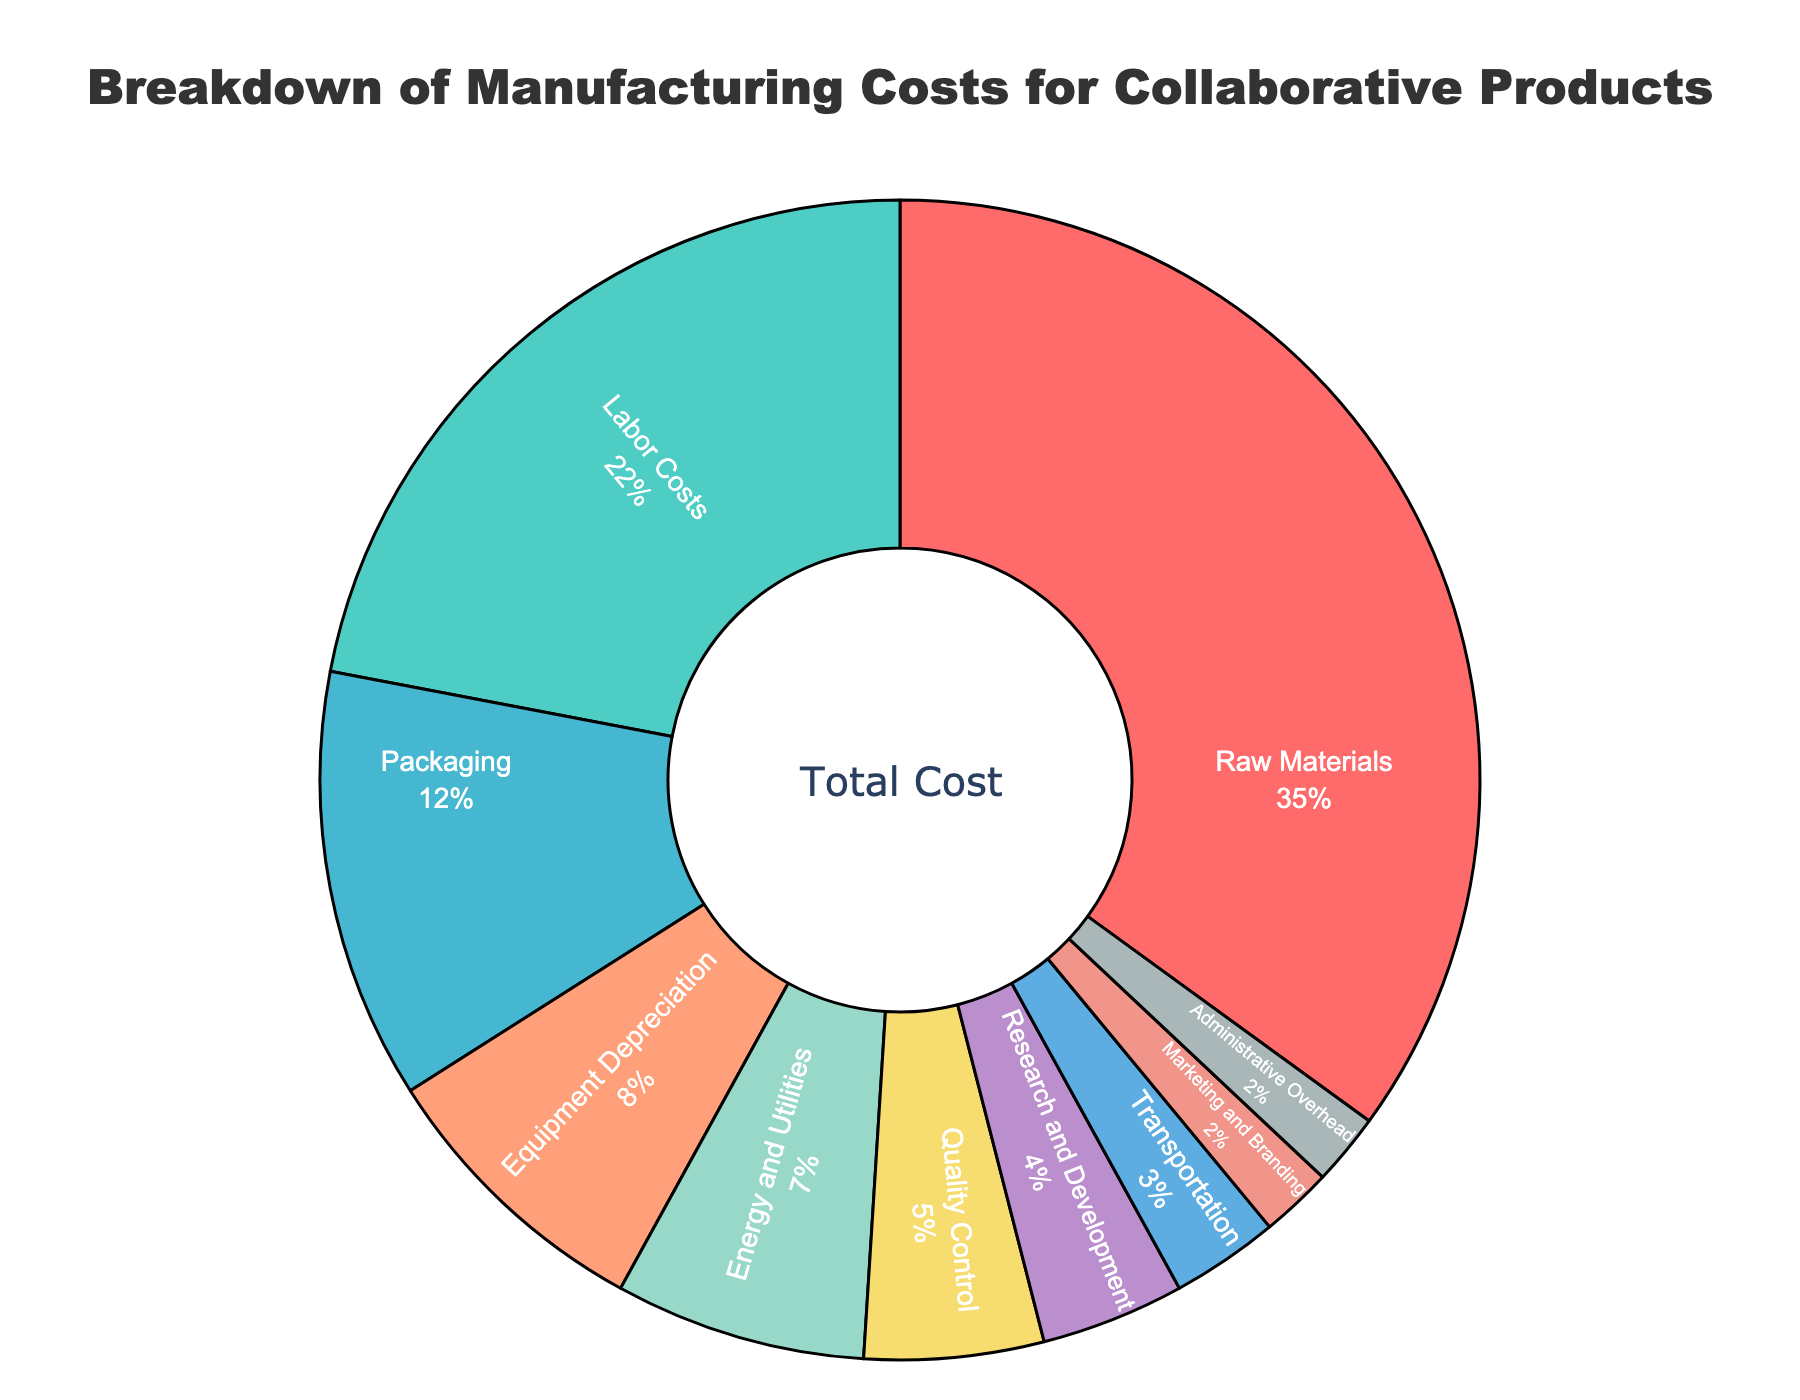what category has the highest percentage in the manufacturing costs? The highest percentage can be identified by observing the largest section of the pie chart. The category with the highest value in the figure is the Raw Materials section, which accounts for 35% of the costs.
Answer: Raw Materials what is the combined percentage of Labor Costs and Packaging? Sum the percentages of Labor Costs (22%) and Packaging (12%) to get the combined value. 22% + 12% equals 34%.
Answer: 34% how does the percentage of Equipment Depreciation compare to Quality Control? Equipment Depreciation has 8% while Quality Control has 5%. Since 8% is greater than 5%, Equipment Depreciation is higher.
Answer: Equipment Depreciation is higher how much more is spent on Energy and Utilities than on Transportation? The difference between Energy and Utilities (7%) and Transportation (3%) is 7% - 3% = 4%.
Answer: 4% what is the collective percentage for Research and Development and Administrative Overhead? Add the percentages for Research and Development (4%) and Administrative Overhead (2%). 4% + 2% equals 6%.
Answer: 6% among Raw Materials, Labor Costs, and Packaging, which is the smallest category? The smallest percentage among Raw Materials (35%), Labor Costs (22%), and Packaging (12%) is Packaging at 12%.
Answer: Packaging are Marketing and Branding larger than Administrative Overhead in percentage? Marketing and Branding and Administrative Overhead both have the same percentage of 2%.
Answer: They are equal what portion of the total costs do categories below Equipment Depreciation contribute? Sum the percentages of categories below Equipment Depreciation: Energy and Utilities (7%) + Quality Control (5%) + Research and Development (4%) + Transportation (3%) + Marketing and Branding (2%) + Administrative Overhead (2%). This totals 23%.
Answer: 23% is the percentage for Raw Materials more than double that of Labor Costs? Labor Costs is 22%. Double would be 44%, which is more than the 35% for Raw Materials. So, Raw Materials is not more than double Labor Costs.
Answer: No what color represents the Labor Costs section and which color is used for Equipment Depreciation? In the pie chart, Labor Costs is represented in a lighter shade of color closer to teal, while Equipment Depreciation is shown in a peachy orange color.
Answer: Teal for Labor Costs, Peachy orange for Equipment Depreciation 